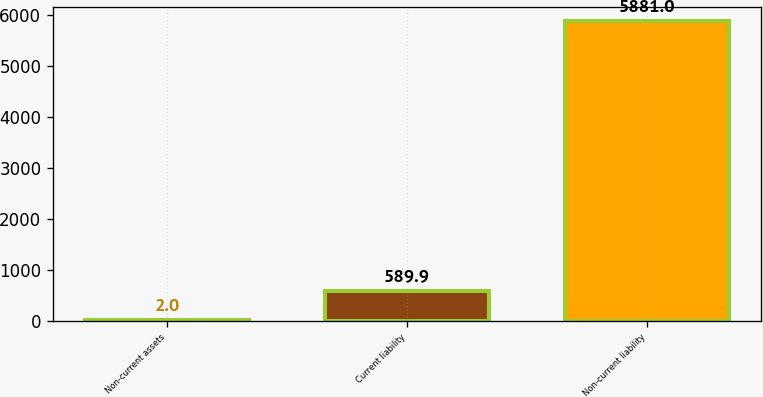Convert chart. <chart><loc_0><loc_0><loc_500><loc_500><bar_chart><fcel>Non-current assets<fcel>Current liability<fcel>Non-current liability<nl><fcel>2<fcel>589.9<fcel>5881<nl></chart> 